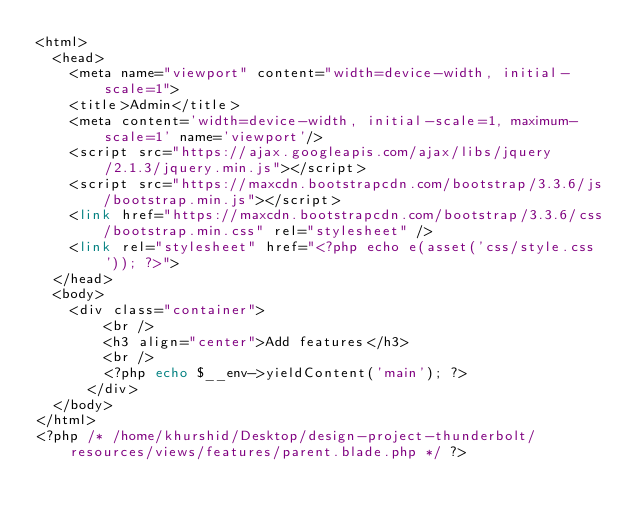<code> <loc_0><loc_0><loc_500><loc_500><_PHP_><html>
	<head>
		<meta name="viewport" content="width=device-width, initial-scale=1">
		<title>Admin</title>
		<meta content='width=device-width, initial-scale=1, maximum-scale=1' name='viewport'/>
		<script src="https://ajax.googleapis.com/ajax/libs/jquery/2.1.3/jquery.min.js"></script>
		<script src="https://maxcdn.bootstrapcdn.com/bootstrap/3.3.6/js/bootstrap.min.js"></script>
		<link href="https://maxcdn.bootstrapcdn.com/bootstrap/3.3.6/css/bootstrap.min.css" rel="stylesheet" />
		<link rel="stylesheet" href="<?php echo e(asset('css/style.css')); ?>">
	</head>
	<body>
		<div class="container">    
  			<br />
  			<h3 align="center">Add features</h3>
  			<br />
  			<?php echo $__env->yieldContent('main'); ?>
  		</div>
	</body>
</html>
<?php /* /home/khurshid/Desktop/design-project-thunderbolt/resources/views/features/parent.blade.php */ ?></code> 